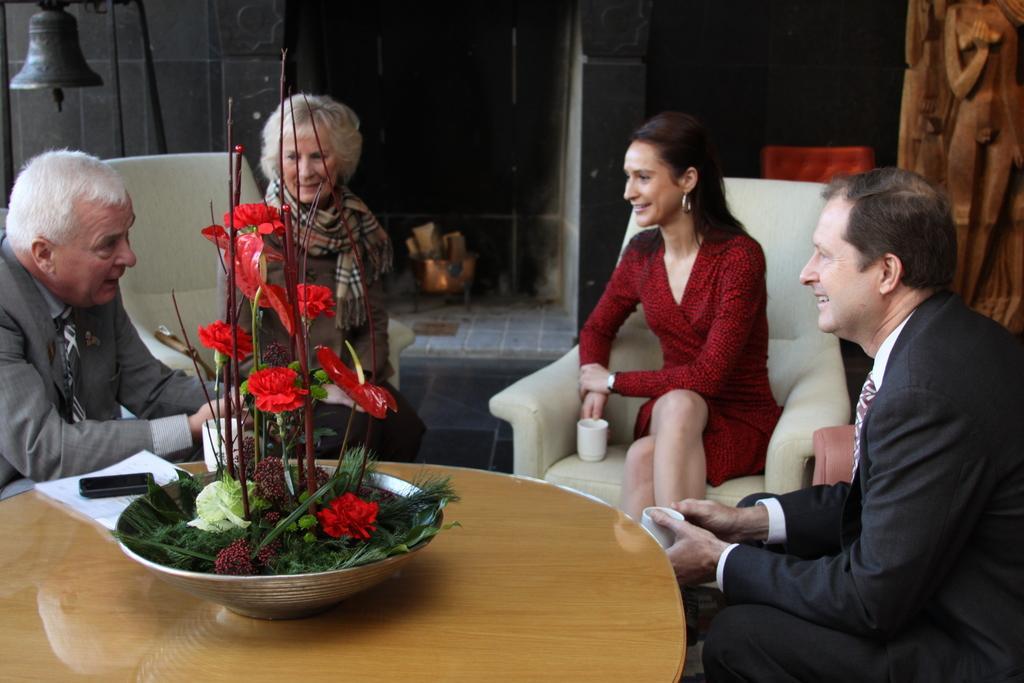Describe this image in one or two sentences. In this image there are people sitting on the chair. In front of them there is a table and on top of the table there is a flower pot, papers and a mobile. Behind them there is a wall. On the left side of the image there is a bell. On the right side of the image there is a wooden structure. In the center of the image there is a fire station. 